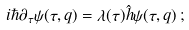<formula> <loc_0><loc_0><loc_500><loc_500>i \hbar { \partial } _ { \tau } \psi ( \tau , q ) = \lambda ( \tau ) \hat { h } \psi ( \tau , q ) \, ;</formula> 